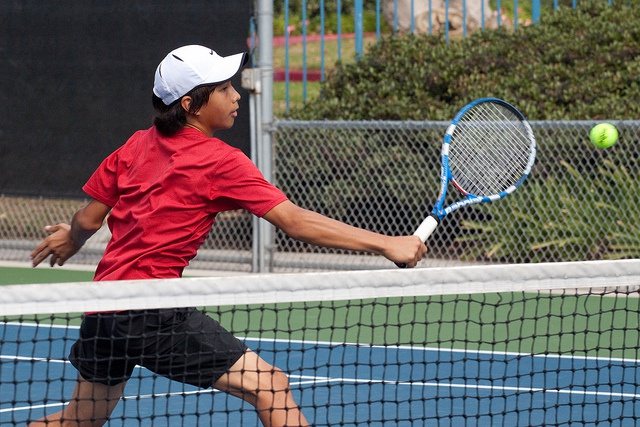Describe the objects in this image and their specific colors. I can see people in black, maroon, and brown tones, tennis racket in black, darkgray, gray, and lightgray tones, and sports ball in black, khaki, lightgreen, and olive tones in this image. 